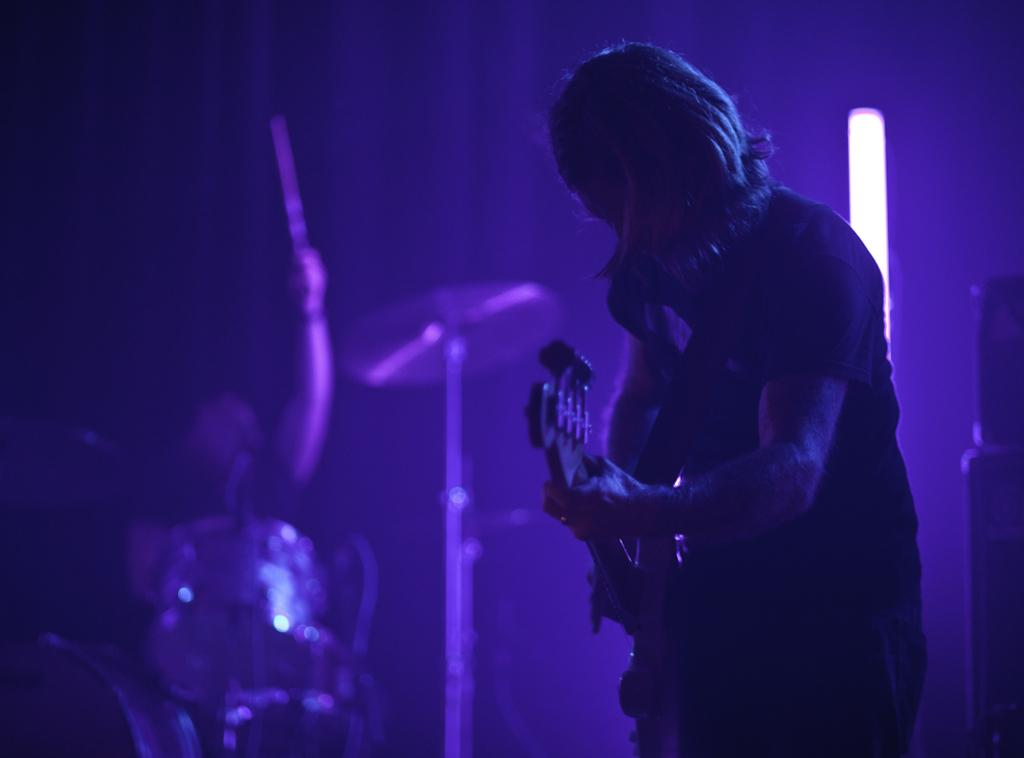What are the two men in the image doing? One man is playing a guitar, and the other is playing the drums. What musical instruments are being played in the image? A guitar and drums are being played in the image. Can you describe the lighting in the image? There is a tube light near a wall in the image. Where is the toothbrush located in the image? There is no toothbrush present in the image. What type of curve can be seen in the image? There is no curve visible in the image; it features two men playing musical instruments and a tube light near a wall. 